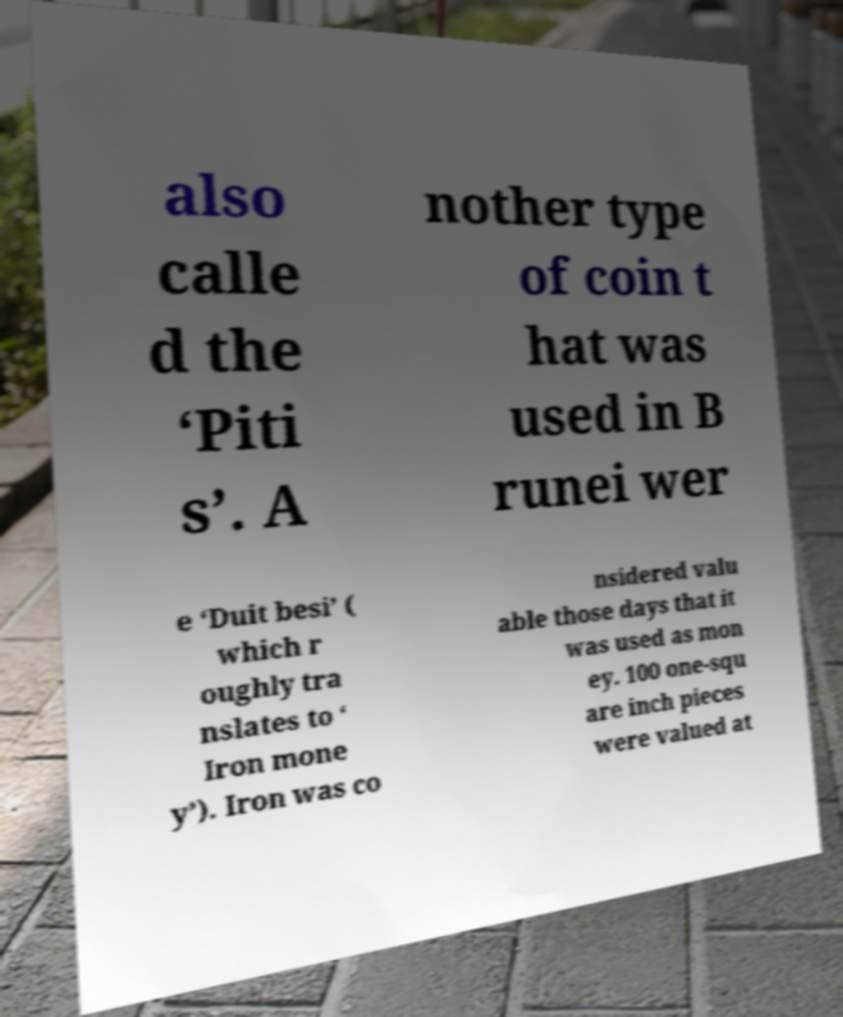There's text embedded in this image that I need extracted. Can you transcribe it verbatim? also calle d the ‘Piti s’. A nother type of coin t hat was used in B runei wer e ‘Duit besi’ ( which r oughly tra nslates to ‘ Iron mone y’). Iron was co nsidered valu able those days that it was used as mon ey. 100 one-squ are inch pieces were valued at 